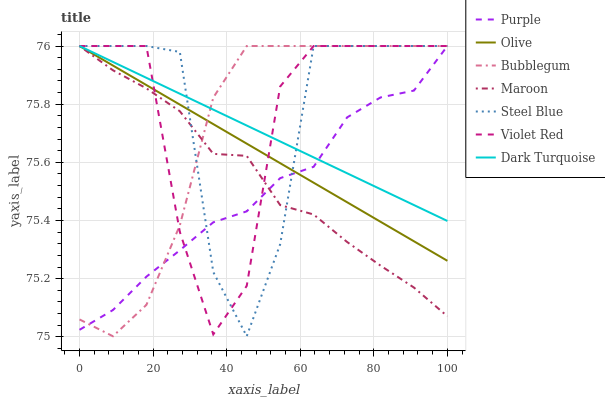Does Purple have the minimum area under the curve?
Answer yes or no. Yes. Does Steel Blue have the maximum area under the curve?
Answer yes or no. Yes. Does Dark Turquoise have the minimum area under the curve?
Answer yes or no. No. Does Dark Turquoise have the maximum area under the curve?
Answer yes or no. No. Is Dark Turquoise the smoothest?
Answer yes or no. Yes. Is Steel Blue the roughest?
Answer yes or no. Yes. Is Purple the smoothest?
Answer yes or no. No. Is Purple the roughest?
Answer yes or no. No. Does Bubblegum have the lowest value?
Answer yes or no. Yes. Does Purple have the lowest value?
Answer yes or no. No. Does Olive have the highest value?
Answer yes or no. Yes. Does Olive intersect Steel Blue?
Answer yes or no. Yes. Is Olive less than Steel Blue?
Answer yes or no. No. Is Olive greater than Steel Blue?
Answer yes or no. No. 